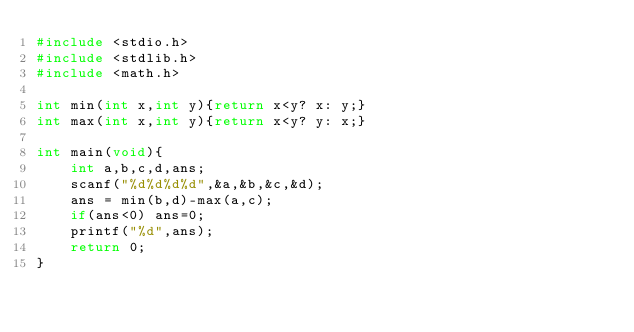Convert code to text. <code><loc_0><loc_0><loc_500><loc_500><_C_>#include <stdio.h>
#include <stdlib.h>
#include <math.h>

int min(int x,int y){return x<y? x: y;}
int max(int x,int y){return x<y? y: x;}

int main(void){
	int a,b,c,d,ans;
	scanf("%d%d%d%d",&a,&b,&c,&d);
	ans = min(b,d)-max(a,c);
	if(ans<0) ans=0;
	printf("%d",ans);
	return 0;
}</code> 